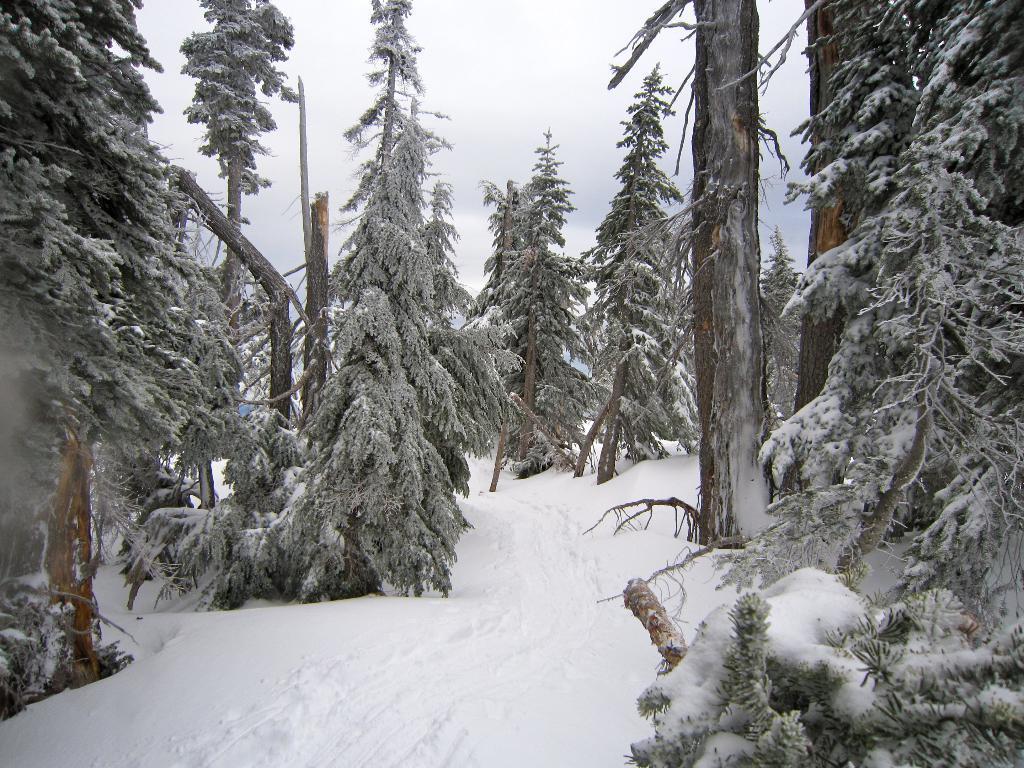Please provide a concise description of this image. In this image we can see the trees and also the snow. We can also see the sky. 